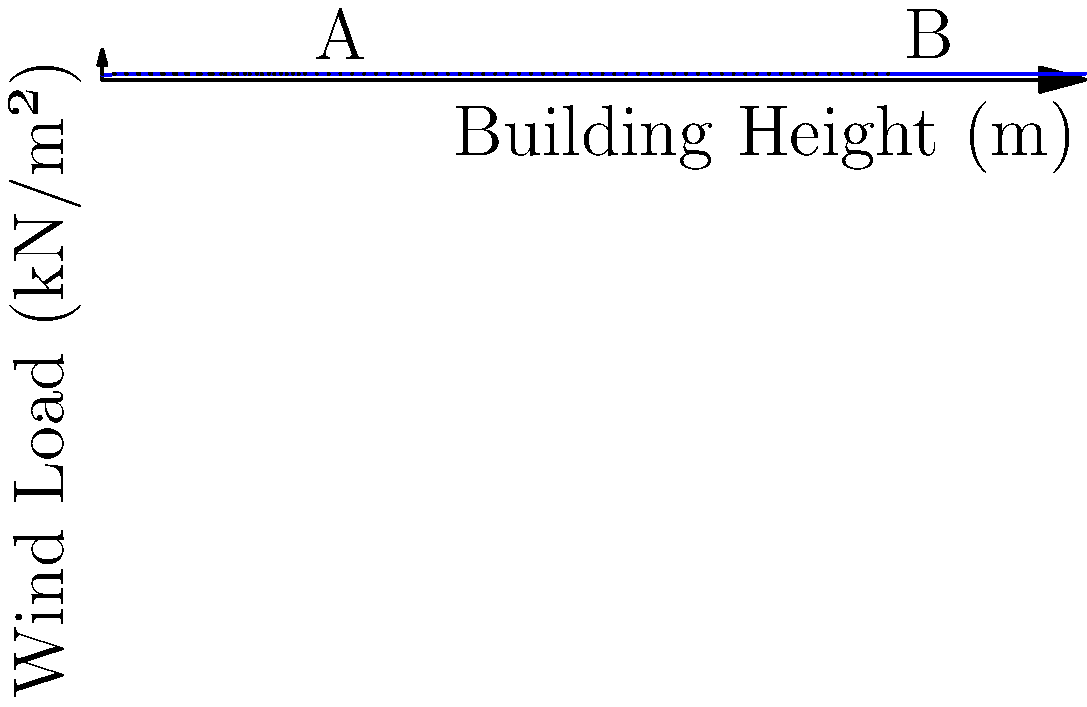As a saxophonist performing near the Seine, you've noticed tall buildings along the riverbank. The graph shows the relationship between building height and wind load. If the wind load at point A (20m height) is 1 kN/m², what is the approximate wind load at point B (80m height)? To solve this problem, we'll follow these steps:

1. Understand the graph:
   - The x-axis represents building height in meters.
   - The y-axis represents wind load in kN/m².
   - The curve shows how wind load increases with building height.

2. Identify the given information:
   - Point A is at 20m height with a wind load of 1 kN/m².
   - Point B is at 80m height.

3. Observe the relationship:
   - The wind load increases non-linearly with height.
   - The curve resembles a cube root function: $f(x) = a + bx^{1/3}$

4. Estimate the wind load at point B:
   - Visually, the wind load at 80m is about 1.5 times the load at 20m.
   - We can approximate: Wind load at B ≈ 1 kN/m² × 1.5 = 1.5 kN/m²

5. Verify with the cube root relationship:
   - If $f(x) = a + bx^{1/3}$, then $f(80) / f(20) = (a + b(80)^{1/3}) / (a + b(20)^{1/3})$
   - This ratio is approximately 1.5, confirming our visual estimate.

Therefore, the approximate wind load at point B (80m height) is 1.5 kN/m².
Answer: 1.5 kN/m² 